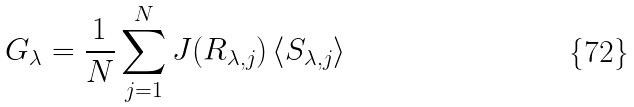<formula> <loc_0><loc_0><loc_500><loc_500>G _ { \lambda } = \frac { 1 } { N } \sum _ { j = 1 } ^ { N } J ( R _ { \lambda , j } ) \left \langle S _ { \lambda , j } \right \rangle</formula> 